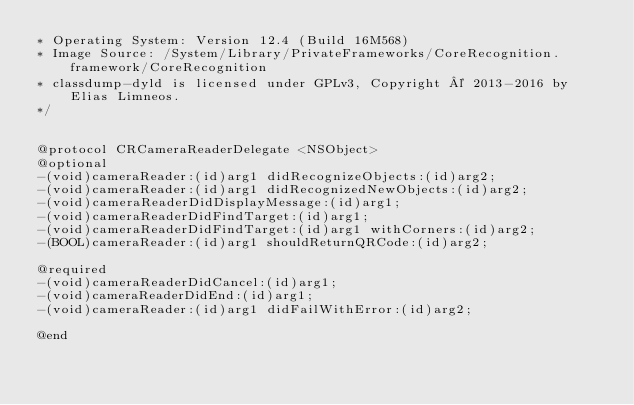Convert code to text. <code><loc_0><loc_0><loc_500><loc_500><_C_>* Operating System: Version 12.4 (Build 16M568)
* Image Source: /System/Library/PrivateFrameworks/CoreRecognition.framework/CoreRecognition
* classdump-dyld is licensed under GPLv3, Copyright © 2013-2016 by Elias Limneos.
*/


@protocol CRCameraReaderDelegate <NSObject>
@optional
-(void)cameraReader:(id)arg1 didRecognizeObjects:(id)arg2;
-(void)cameraReader:(id)arg1 didRecognizedNewObjects:(id)arg2;
-(void)cameraReaderDidDisplayMessage:(id)arg1;
-(void)cameraReaderDidFindTarget:(id)arg1;
-(void)cameraReaderDidFindTarget:(id)arg1 withCorners:(id)arg2;
-(BOOL)cameraReader:(id)arg1 shouldReturnQRCode:(id)arg2;

@required
-(void)cameraReaderDidCancel:(id)arg1;
-(void)cameraReaderDidEnd:(id)arg1;
-(void)cameraReader:(id)arg1 didFailWithError:(id)arg2;

@end

</code> 